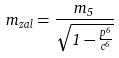<formula> <loc_0><loc_0><loc_500><loc_500>m _ { z a l } = \frac { m _ { 5 } } { \sqrt { 1 - \frac { p ^ { 6 } } { c ^ { 6 } } } }</formula> 